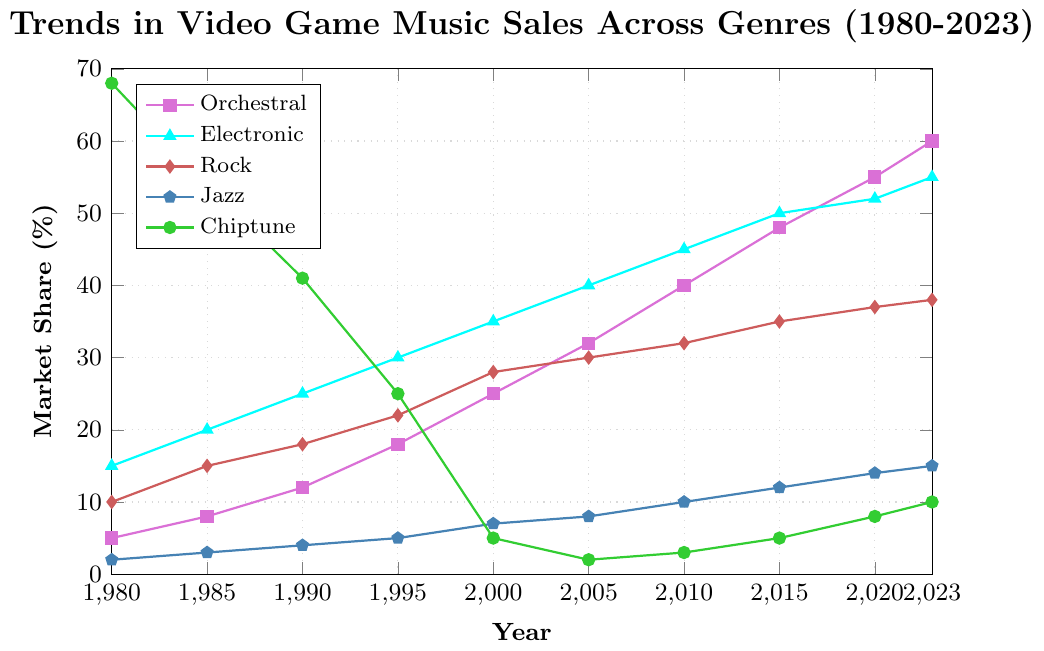What genre has the highest market share in 1980? In 1980, Chiptune has the highest market share as indicated by the data point at 68%.
Answer: Chiptune Which genre experienced the greatest increase in market share between 1980 and 2023? From the graph, Orchestral music increased from 5% in 1980 to 60% in 2023, showing a growth of 55%. No other genre has a larger growth.
Answer: Orchestral What’s the market share difference between Rock and Orchestral in 2000? In 2000, Rock has a market share of 28% while Orchestral has 25%. The difference is 28% - 25% = 3%.
Answer: 3% Which genre had a market share of 50% in 2015? By checking the figure for the year 2015, Electronic music had a market share of 50%.
Answer: Electronic What are the trends of Chiptune music sales from 1980 to 2023? The market share of Chiptune music shows a decline from 68% in 1980 to just 2% in 2005, but then it starts to gradually rise again, reaching 10% by 2023.
Answer: Decreasing then gradually increasing Between which years did Jazz music see the highest increase in its market share percentage? Jazz music increased from 2% in 1980 to 15% in 2023. The highest increase looks to occur between 2005 (8%) and 2010 (10%), where it gained the most within a short interval.
Answer: 2005-2010 By how much did the market share of Electronic music change between 2010 and 2020? Electronic music saw a change from 45% in 2010 to 52% in 2020. Therefore, the change is 52% - 45% = 7%.
Answer: 7% What genre had a decreasing trend consistently until the year 2000? Chiptune music had a consistent declining trend from 68% in 1980 to 5% in 2000.
Answer: Chiptune In which year did Rock music achieve a market share of 30%? By observing the trend, Rock music achieved a 30% market share in the year 2005.
Answer: 2005 Which two genres had a market share of around 10% or less in 1980? In 1980, Jazz had a 2% market share and Rock had a 10% market share.
Answer: Jazz, Rock 